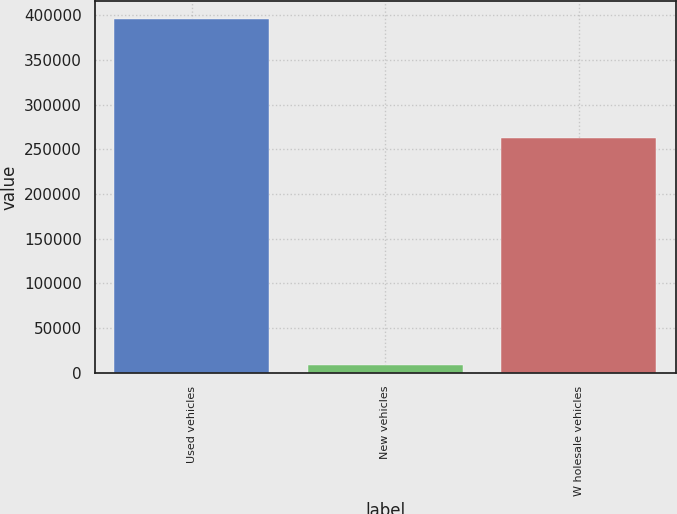<chart> <loc_0><loc_0><loc_500><loc_500><bar_chart><fcel>Used vehicles<fcel>New vehicles<fcel>W holesale vehicles<nl><fcel>396181<fcel>8231<fcel>263061<nl></chart> 